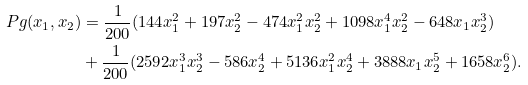Convert formula to latex. <formula><loc_0><loc_0><loc_500><loc_500>P g ( x _ { 1 } , x _ { 2 } ) & = \frac { 1 } { 2 0 0 } ( 1 4 4 x _ { 1 } ^ { 2 } + 1 9 7 x _ { 2 } ^ { 2 } - 4 7 4 x _ { 1 } ^ { 2 } x _ { 2 } ^ { 2 } + 1 0 9 8 x _ { 1 } ^ { 4 } x _ { 2 } ^ { 2 } - 6 4 8 x _ { 1 } x _ { 2 } ^ { 3 } ) \\ & + \frac { 1 } { 2 0 0 } ( 2 5 9 2 x _ { 1 } ^ { 3 } x _ { 2 } ^ { 3 } - 5 8 6 x _ { 2 } ^ { 4 } + 5 1 3 6 x _ { 1 } ^ { 2 } x _ { 2 } ^ { 4 } + 3 8 8 8 x _ { 1 } x _ { 2 } ^ { 5 } + 1 6 5 8 x _ { 2 } ^ { 6 } ) .</formula> 